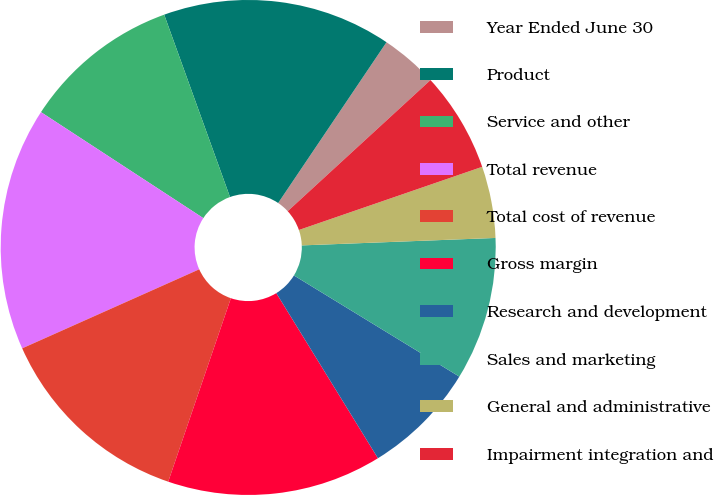Convert chart to OTSL. <chart><loc_0><loc_0><loc_500><loc_500><pie_chart><fcel>Year Ended June 30<fcel>Product<fcel>Service and other<fcel>Total revenue<fcel>Total cost of revenue<fcel>Gross margin<fcel>Research and development<fcel>Sales and marketing<fcel>General and administrative<fcel>Impairment integration and<nl><fcel>3.74%<fcel>14.95%<fcel>10.28%<fcel>15.89%<fcel>13.08%<fcel>14.02%<fcel>7.48%<fcel>9.35%<fcel>4.67%<fcel>6.54%<nl></chart> 